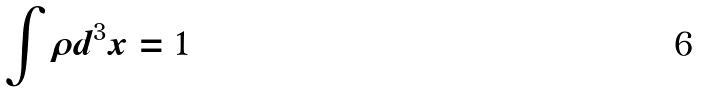Convert formula to latex. <formula><loc_0><loc_0><loc_500><loc_500>\int \rho d ^ { 3 } x = 1</formula> 